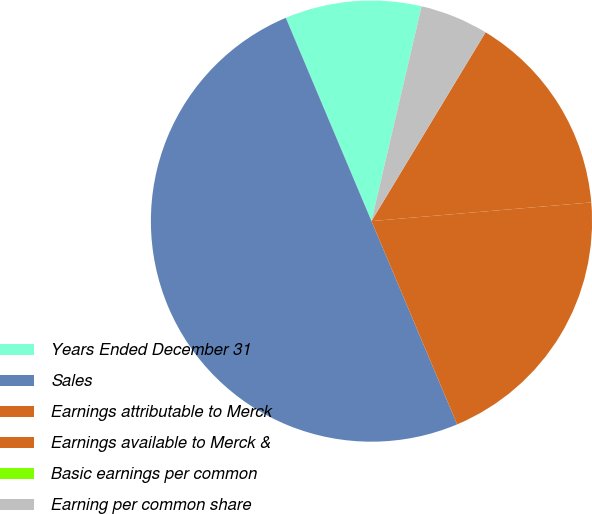Convert chart. <chart><loc_0><loc_0><loc_500><loc_500><pie_chart><fcel>Years Ended December 31<fcel>Sales<fcel>Earnings attributable to Merck<fcel>Earnings available to Merck &<fcel>Basic earnings per common<fcel>Earning per common share<nl><fcel>10.0%<fcel>50.0%<fcel>20.0%<fcel>15.0%<fcel>0.0%<fcel>5.0%<nl></chart> 